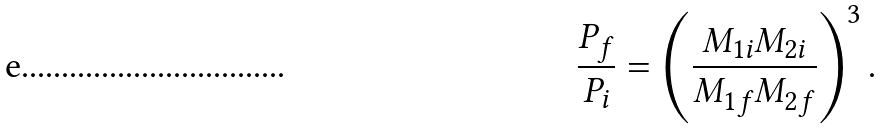<formula> <loc_0><loc_0><loc_500><loc_500>\frac { P _ { f } } { P _ { i } } = \left ( \frac { M _ { 1 i } M _ { 2 i } } { M _ { 1 f } M _ { 2 f } } \right ) ^ { 3 } .</formula> 